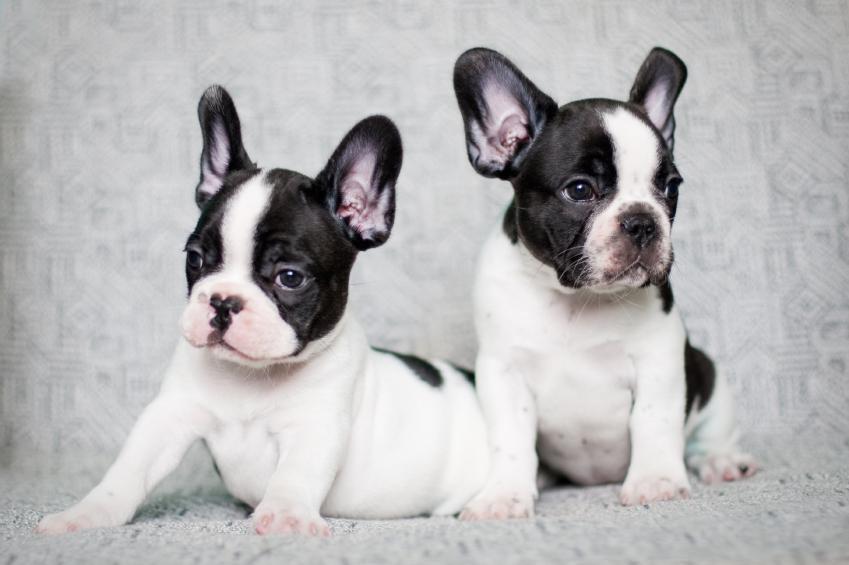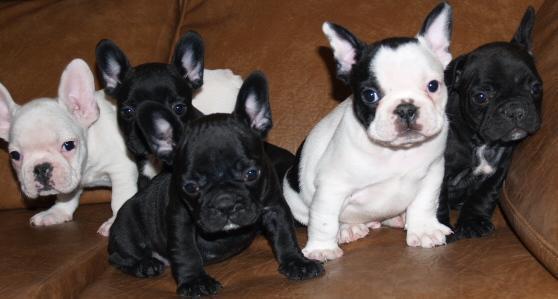The first image is the image on the left, the second image is the image on the right. Considering the images on both sides, is "There is no more than three dogs in the right image." valid? Answer yes or no. No. The first image is the image on the left, the second image is the image on the right. Assess this claim about the two images: "An image shows at least three dogs, including a black one, all posed together on a fabric covered seat.". Correct or not? Answer yes or no. Yes. 